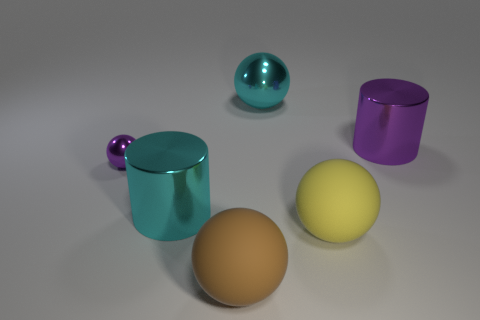Add 3 brown spheres. How many objects exist? 9 Subtract all cylinders. How many objects are left? 4 Subtract all cyan spheres. Subtract all big purple shiny objects. How many objects are left? 4 Add 1 large shiny cylinders. How many large shiny cylinders are left? 3 Add 2 big shiny balls. How many big shiny balls exist? 3 Subtract 0 yellow cylinders. How many objects are left? 6 